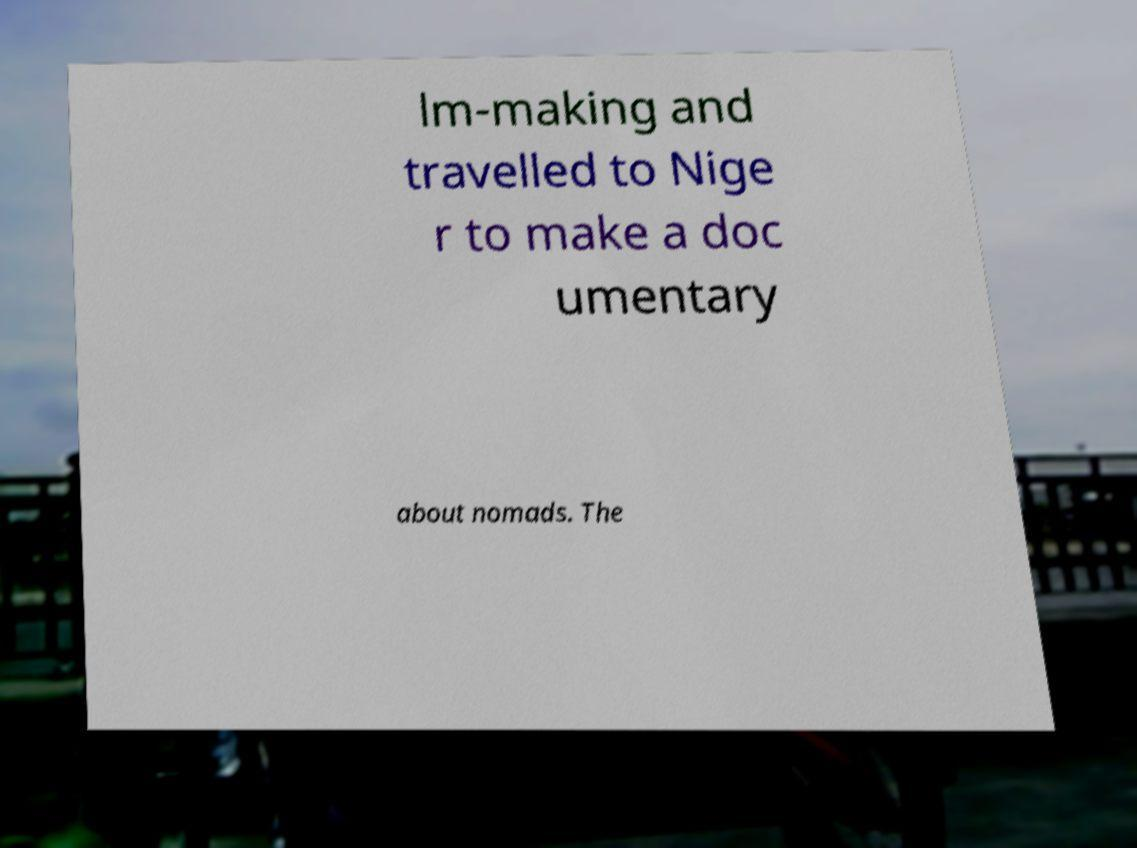Can you accurately transcribe the text from the provided image for me? lm-making and travelled to Nige r to make a doc umentary about nomads. The 